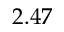<formula> <loc_0><loc_0><loc_500><loc_500>2 . 4 7</formula> 